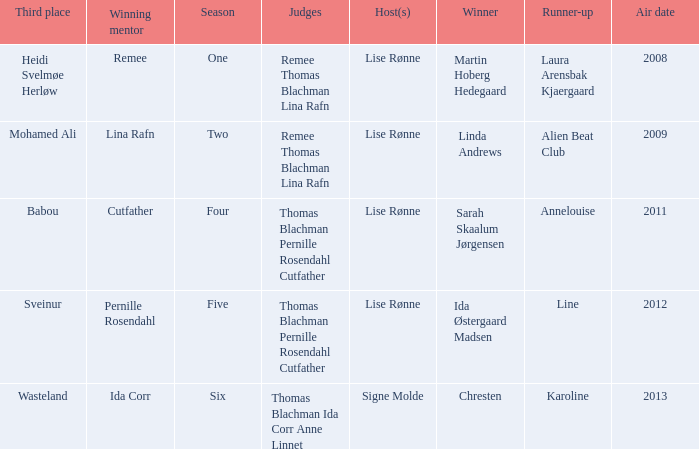Which season did Ida Corr win? Six. Parse the table in full. {'header': ['Third place', 'Winning mentor', 'Season', 'Judges', 'Host(s)', 'Winner', 'Runner-up', 'Air date'], 'rows': [['Heidi Svelmøe Herløw', 'Remee', 'One', 'Remee Thomas Blachman Lina Rafn', 'Lise Rønne', 'Martin Hoberg Hedegaard', 'Laura Arensbak Kjaergaard', '2008'], ['Mohamed Ali', 'Lina Rafn', 'Two', 'Remee Thomas Blachman Lina Rafn', 'Lise Rønne', 'Linda Andrews', 'Alien Beat Club', '2009'], ['Babou', 'Cutfather', 'Four', 'Thomas Blachman Pernille Rosendahl Cutfather', 'Lise Rønne', 'Sarah Skaalum Jørgensen', 'Annelouise', '2011'], ['Sveinur', 'Pernille Rosendahl', 'Five', 'Thomas Blachman Pernille Rosendahl Cutfather', 'Lise Rønne', 'Ida Østergaard Madsen', 'Line', '2012'], ['Wasteland', 'Ida Corr', 'Six', 'Thomas Blachman Ida Corr Anne Linnet', 'Signe Molde', 'Chresten', 'Karoline', '2013']]} 